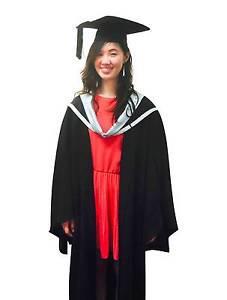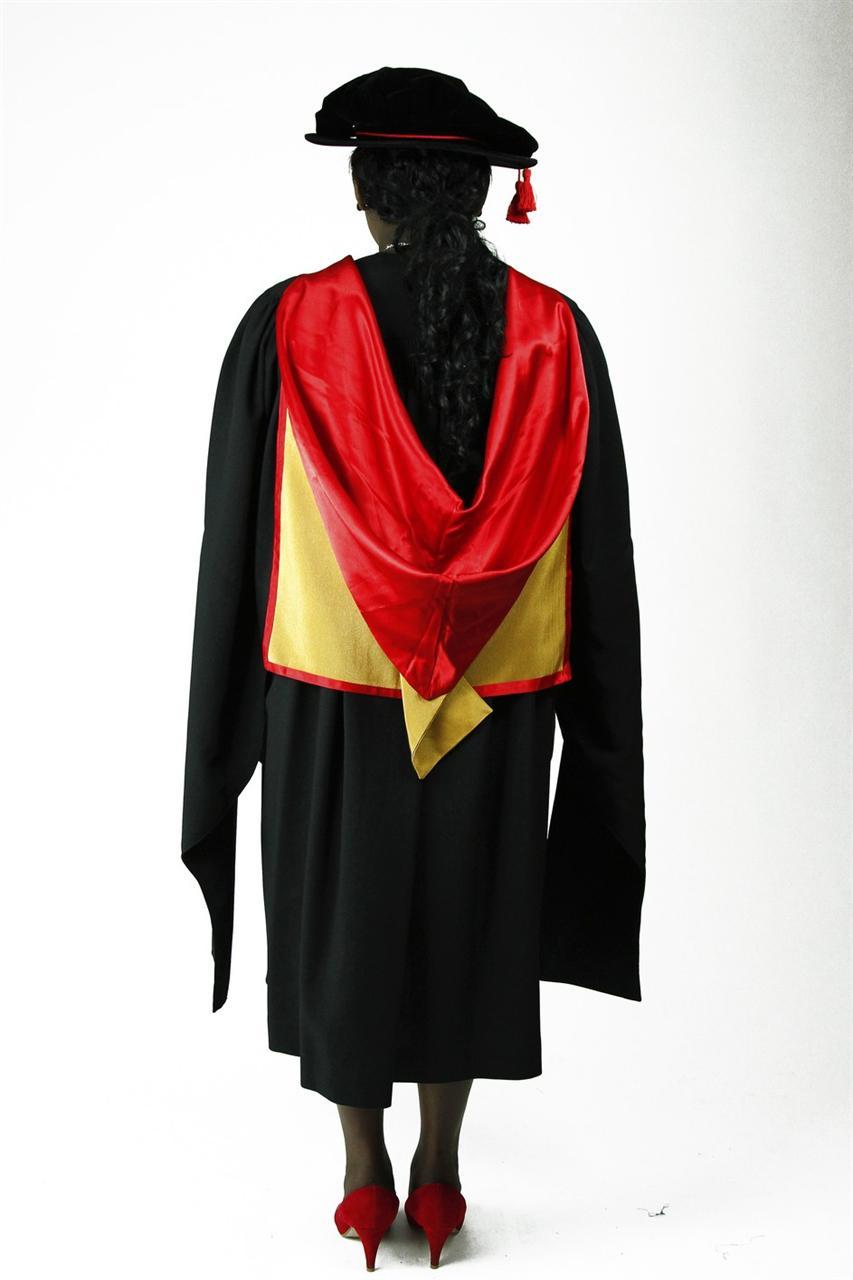The first image is the image on the left, the second image is the image on the right. For the images displayed, is the sentence "The graduate models on the right and left wear black robes with neck sashes and each wears something red." factually correct? Answer yes or no. Yes. The first image is the image on the left, the second image is the image on the right. Given the left and right images, does the statement "Both people are wearing some bright red." hold true? Answer yes or no. Yes. 